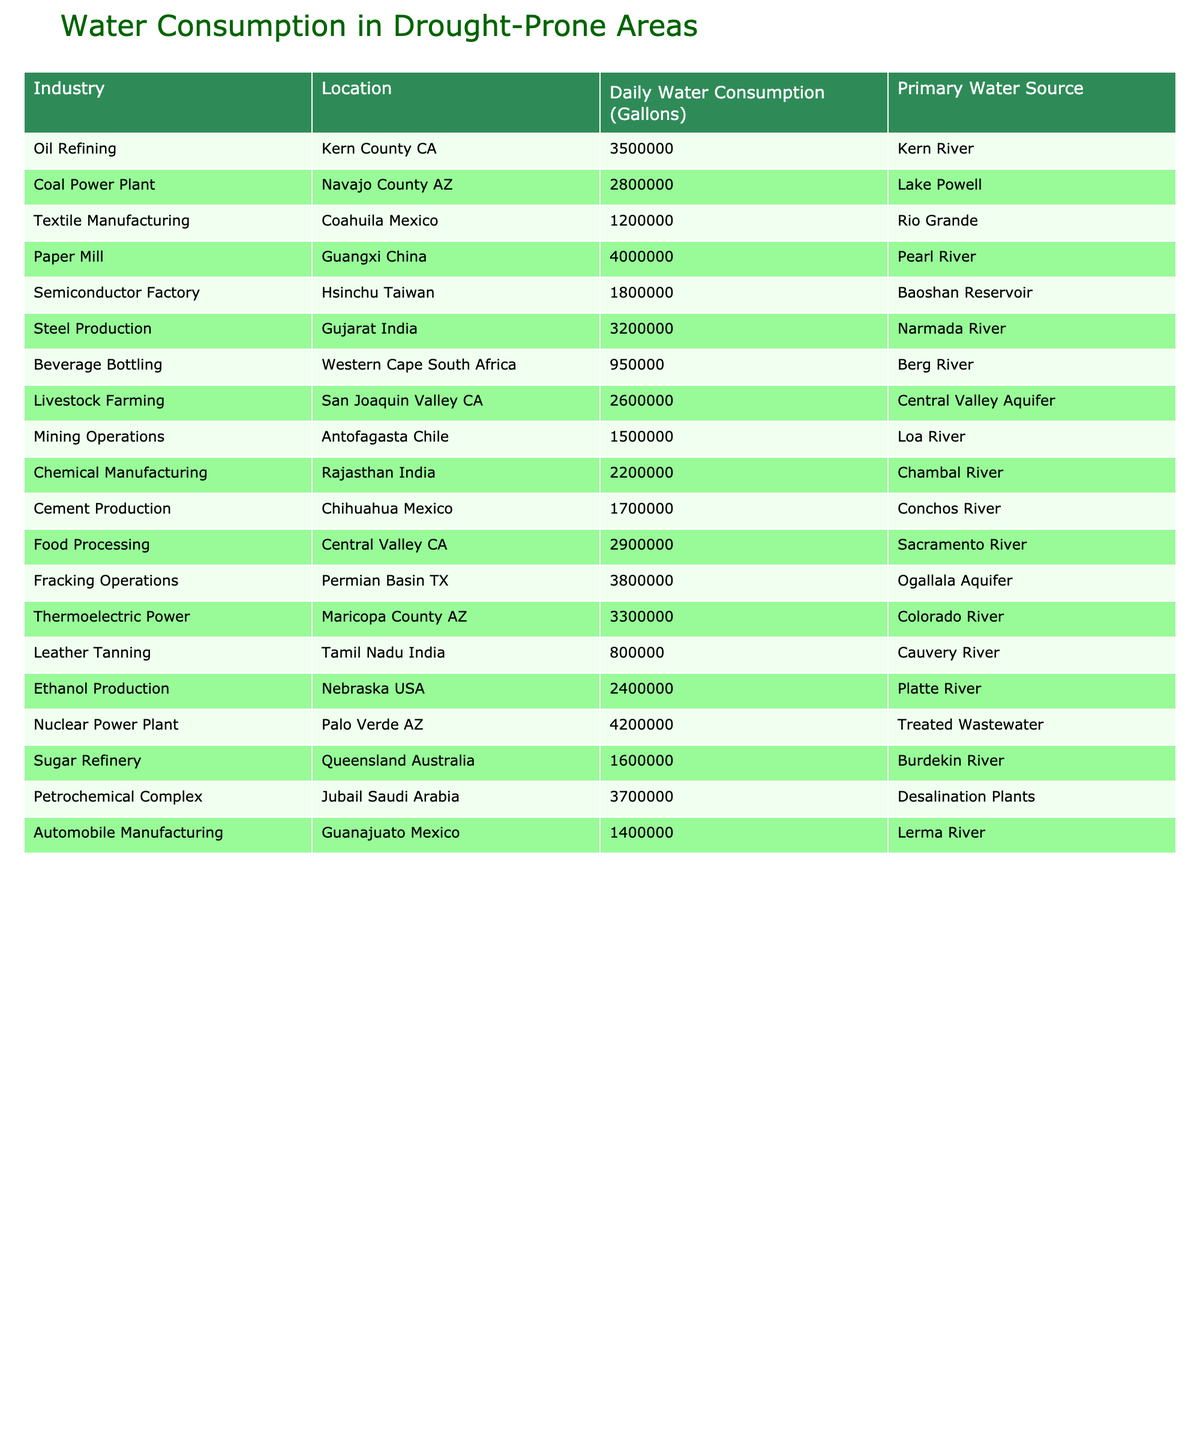What is the daily water consumption of the Nuclear Power Plant? The table shows that the Nuclear Power Plant in Palo Verde AZ has a daily water consumption of 4,200,000 gallons.
Answer: 4,200,000 gallons Which industry consumes the least water daily? Looking through the table, the Leather Tanning industry in Tamil Nadu India has the lowest daily water consumption at 800,000 gallons.
Answer: Leather Tanning What is the total daily water consumption for Fracking Operations and Nuclear Power Plant combined? The daily water consumption for Fracking Operations is 3,800,000 gallons and for Nuclear Power Plant is 4,200,000 gallons. Adding these gives 3,800,000 + 4,200,000 = 8,000,000 gallons.
Answer: 8,000,000 gallons Is the daily water consumption of Mining Operations higher than that of Textile Manufacturing? The table indicates that Mining Operations have a consumption of 1,500,000 gallons, and Textile Manufacturing has 1,200,000 gallons. Since 1,500,000 > 1,200,000, the statement is true.
Answer: Yes What is the average daily water consumption of Oil Refining and Steel Production? The daily water consumption for Oil Refining is 3,500,000 gallons, and for Steel Production, it is 3,200,000 gallons. The sum is 3,500,000 + 3,200,000 = 6,700,000 gallons. To find the average, divide by 2: 6,700,000 / 2 = 3,350,000 gallons.
Answer: 3,350,000 gallons How many industries consume over 3 million gallons of water daily? From the table, we can identify that Oil Refining, Nuclear Power Plant, Fracking Operations, and several others consume more than 3 million gallons. The count is 7 industries total.
Answer: 7 industries What is the difference in daily water consumption between the highest and lowest consuming industries? The highest consumption is from the Nuclear Power Plant at 4,200,000 gallons and the lowest is the Leather Tanning industry at 800,000 gallons. The difference is 4,200,000 - 800,000 = 3,400,000 gallons.
Answer: 3,400,000 gallons Which water source has the highest total consumption from all industries? By calculating the total consumption per water source, the Ogallala Aquifer serves the Fracking Operations (3,800,000 gallons), and the Colorado River for Thermoelectric Power (3,300,000 gallons), summing them shows that it is higher than others. The highest total is from the Colorado River.
Answer: Colorado River Is there any industry listed that does not rely on a natural water source? Checking the table, the Petrochemical Complex in Jubail Saudi Arabia uses desalination plants, which is not a natural source. Thus, there is at least one industry using a non-natural source.
Answer: Yes What is the primary water source for the Paper Mill? According to the table, the Paper Mill in Guangxi China relies on the Pearl River as its primary water source.
Answer: Pearl River 